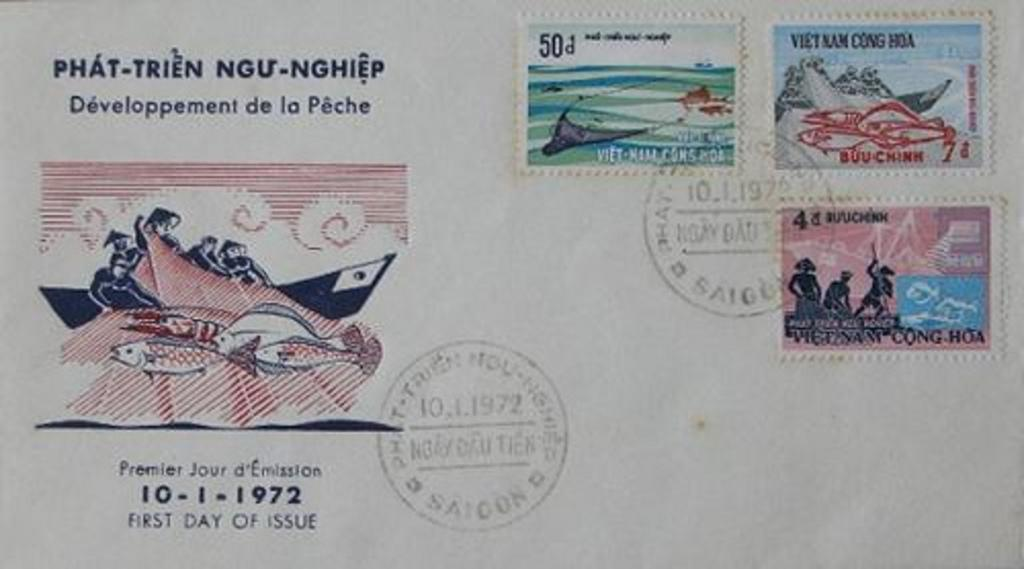<image>
Provide a brief description of the given image. an envelope filled with Vietnam stamps from 1972 